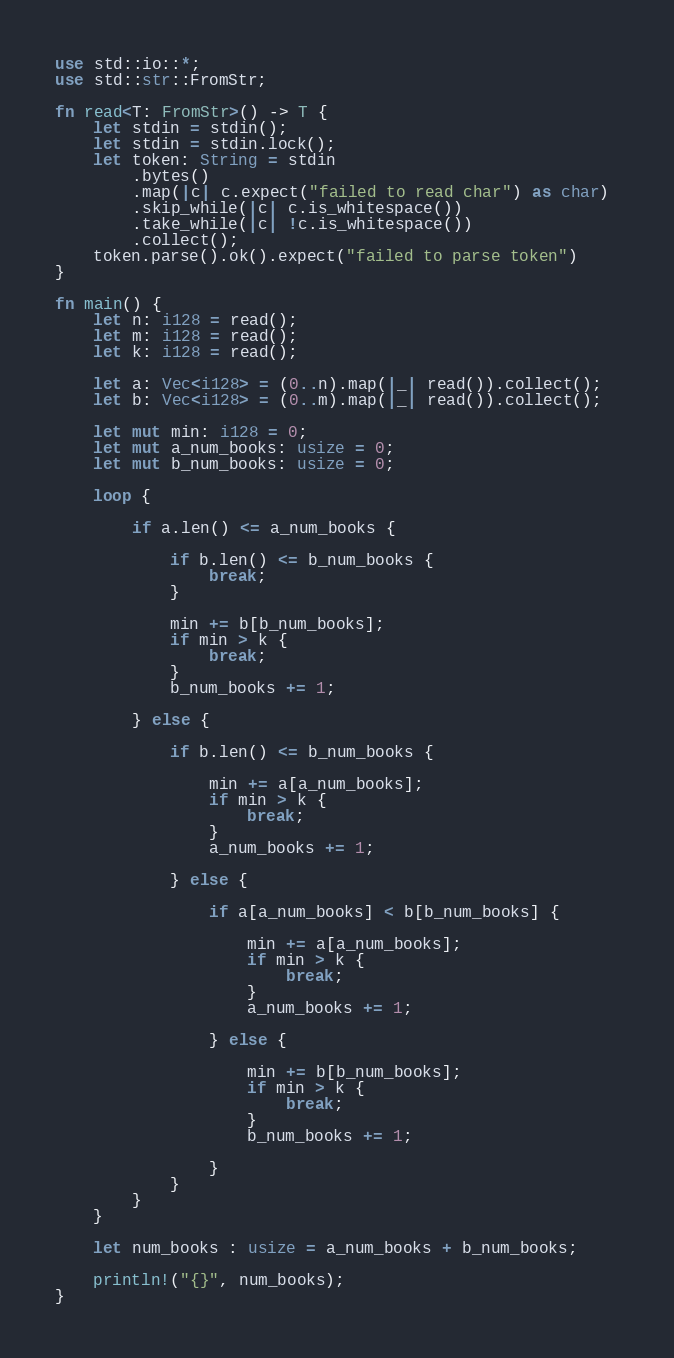<code> <loc_0><loc_0><loc_500><loc_500><_Rust_>use std::io::*;
use std::str::FromStr;

fn read<T: FromStr>() -> T {
    let stdin = stdin();
    let stdin = stdin.lock();
    let token: String = stdin
        .bytes()
        .map(|c| c.expect("failed to read char") as char) 
        .skip_while(|c| c.is_whitespace())
        .take_while(|c| !c.is_whitespace())
        .collect();
    token.parse().ok().expect("failed to parse token")
}

fn main() {
    let n: i128 = read();
    let m: i128 = read();
    let k: i128 = read();

    let a: Vec<i128> = (0..n).map(|_| read()).collect();
    let b: Vec<i128> = (0..m).map(|_| read()).collect();

    let mut min: i128 = 0;
    let mut a_num_books: usize = 0;
    let mut b_num_books: usize = 0;

    loop {

        if a.len() <= a_num_books {

            if b.len() <= b_num_books {
                break;
            }

            min += b[b_num_books];
            if min > k {
                break;    
            }
            b_num_books += 1;

        } else {

            if b.len() <= b_num_books {

                min += a[a_num_books];
                if min > k {
                    break;
                }
                a_num_books += 1;

            } else {

                if a[a_num_books] < b[b_num_books] {

                    min += a[a_num_books];
                    if min > k {
                        break;
                    }
                    a_num_books += 1;

                } else {

                    min += b[b_num_books];
                    if min > k {
                        break;
                    }
                    b_num_books += 1;

                }
            }
        }
    }

    let num_books : usize = a_num_books + b_num_books;

    println!("{}", num_books);
}</code> 